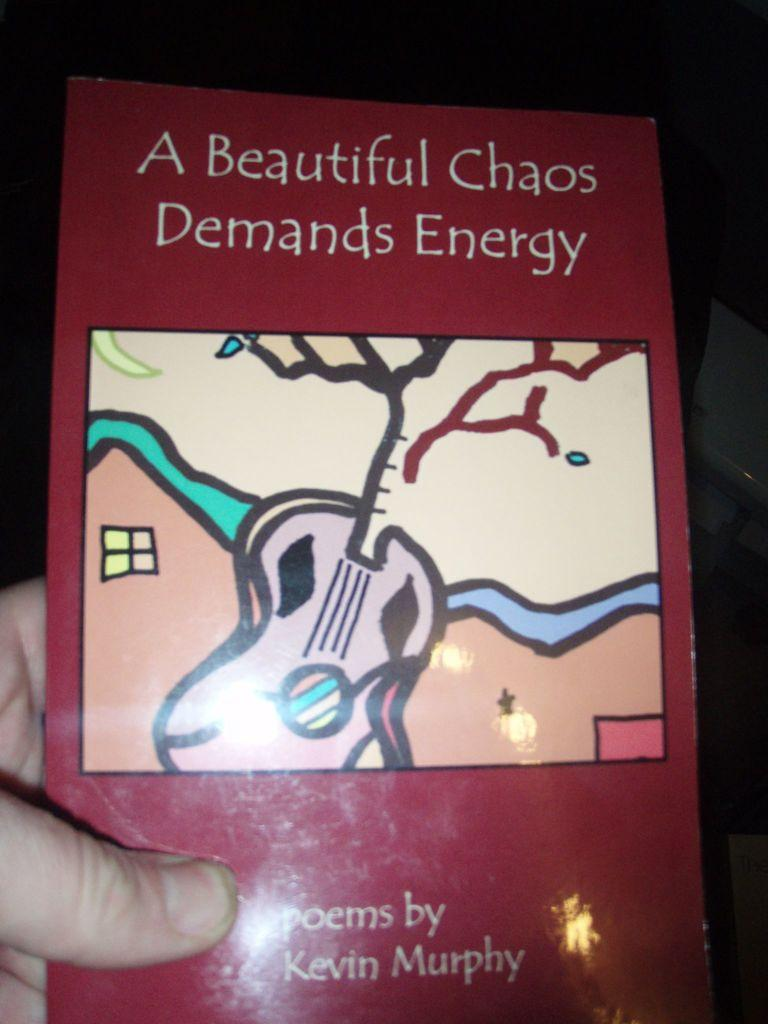<image>
Offer a succinct explanation of the picture presented. A person holds a book of poems by Kevin Murphy. 